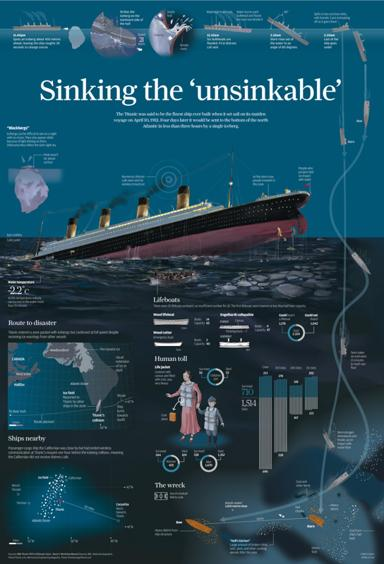Are there any comparisons shown in the infographic related to other ships during the Titanic's era? Yes, the infographic compares the Titanic's size and capabilities with other contemporary ships. It highlights the technological advancements of the Titanic compared to other vessels, emphasizing its design and the safety features that were considered advanced for its time. 